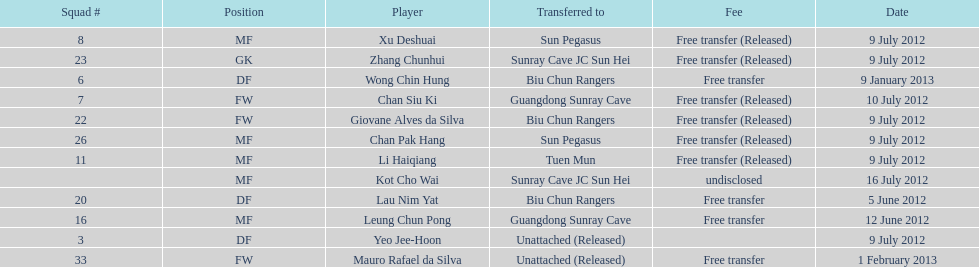Lau nim yat and giovane alves de silva where both transferred to which team? Biu Chun Rangers. 